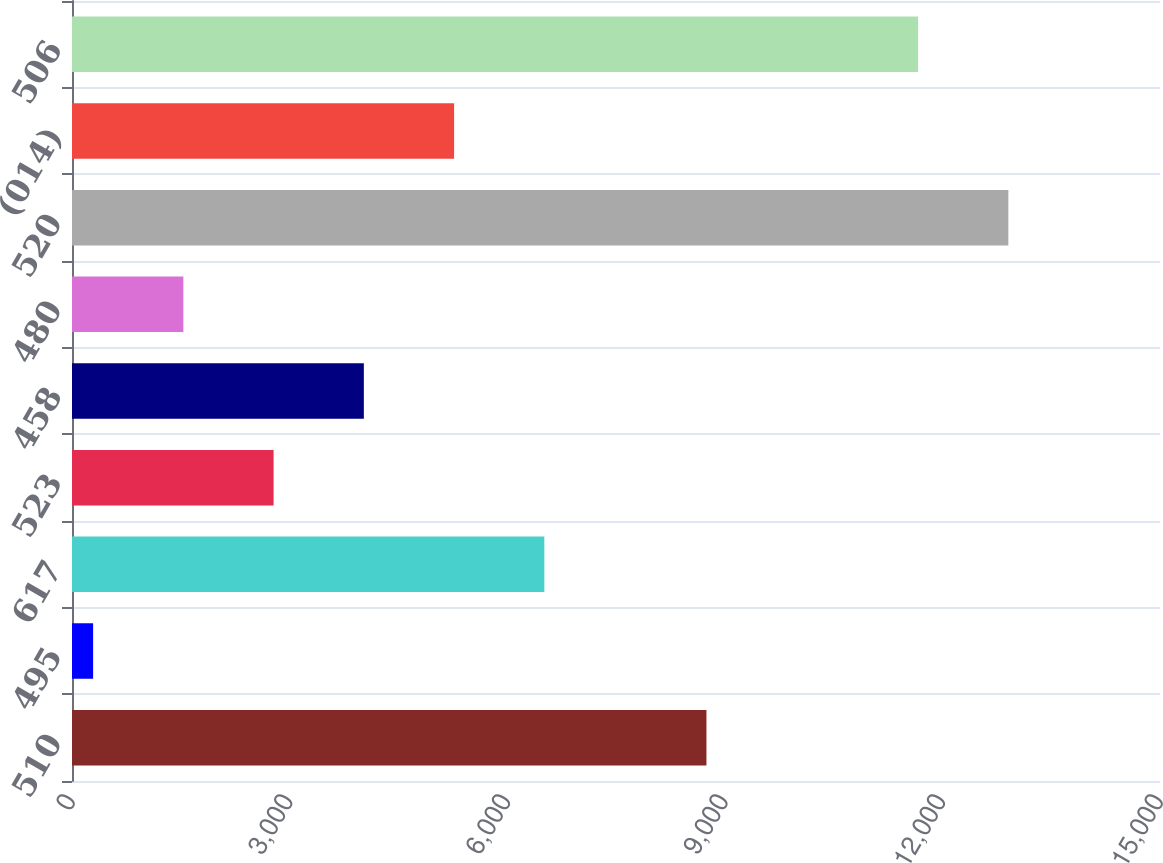Convert chart. <chart><loc_0><loc_0><loc_500><loc_500><bar_chart><fcel>510<fcel>495<fcel>617<fcel>523<fcel>458<fcel>480<fcel>520<fcel>(014)<fcel>506<nl><fcel>8747<fcel>291<fcel>6512<fcel>2779.4<fcel>4023.6<fcel>1535.2<fcel>12909.2<fcel>5267.8<fcel>11665<nl></chart> 